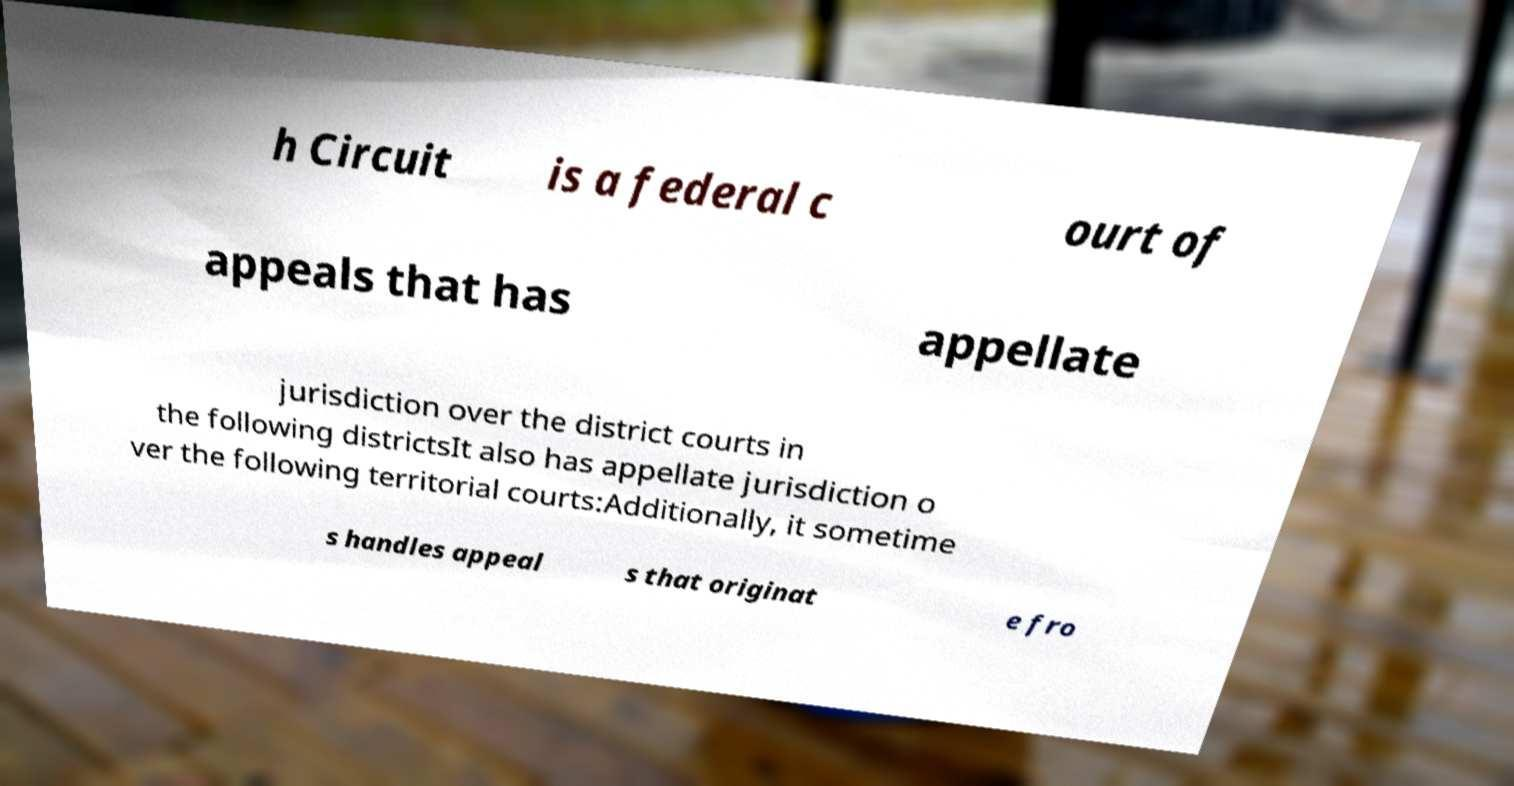For documentation purposes, I need the text within this image transcribed. Could you provide that? h Circuit is a federal c ourt of appeals that has appellate jurisdiction over the district courts in the following districtsIt also has appellate jurisdiction o ver the following territorial courts:Additionally, it sometime s handles appeal s that originat e fro 